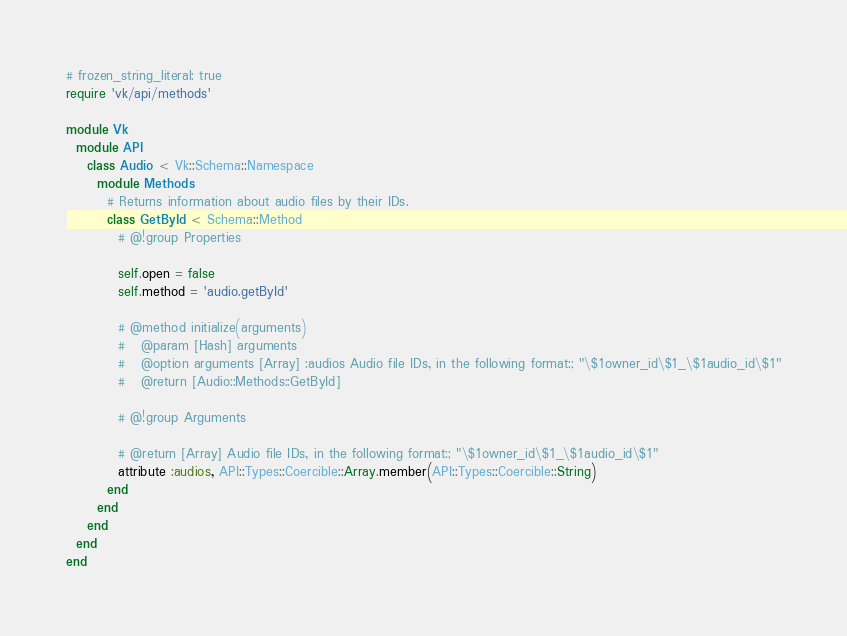Convert code to text. <code><loc_0><loc_0><loc_500><loc_500><_Ruby_># frozen_string_literal: true
require 'vk/api/methods'

module Vk
  module API
    class Audio < Vk::Schema::Namespace
      module Methods
        # Returns information about audio files by their IDs.
        class GetById < Schema::Method
          # @!group Properties

          self.open = false
          self.method = 'audio.getById'

          # @method initialize(arguments)
          #   @param [Hash] arguments
          #   @option arguments [Array] :audios Audio file IDs, in the following format:; "\$1owner_id\$1_\$1audio_id\$1"
          #   @return [Audio::Methods::GetById]

          # @!group Arguments

          # @return [Array] Audio file IDs, in the following format:; "\$1owner_id\$1_\$1audio_id\$1"
          attribute :audios, API::Types::Coercible::Array.member(API::Types::Coercible::String)
        end
      end
    end
  end
end
</code> 